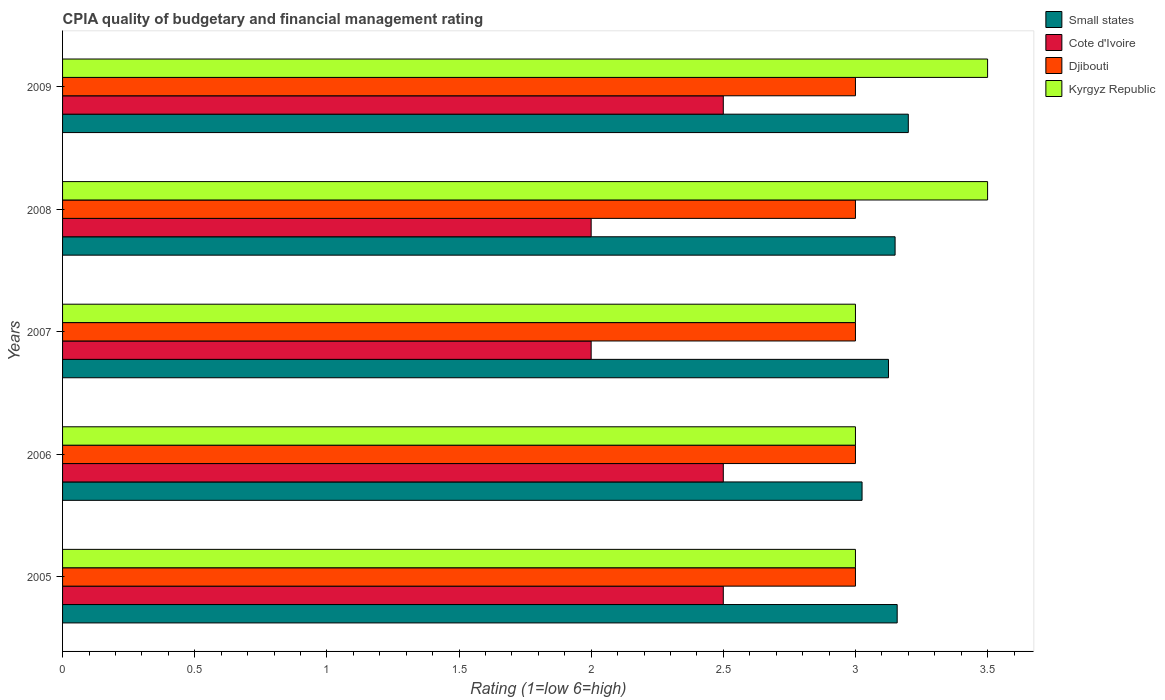How many different coloured bars are there?
Offer a terse response. 4. How many bars are there on the 4th tick from the top?
Provide a succinct answer. 4. What is the CPIA rating in Small states in 2009?
Give a very brief answer. 3.2. Across all years, what is the minimum CPIA rating in Small states?
Give a very brief answer. 3.02. What is the total CPIA rating in Djibouti in the graph?
Your answer should be compact. 15. What is the difference between the CPIA rating in Small states in 2006 and that in 2009?
Your answer should be very brief. -0.18. What is the difference between the CPIA rating in Djibouti in 2006 and the CPIA rating in Small states in 2007?
Your answer should be compact. -0.12. What is the average CPIA rating in Kyrgyz Republic per year?
Provide a succinct answer. 3.2. In how many years, is the CPIA rating in Small states greater than 2.5 ?
Keep it short and to the point. 5. What is the ratio of the CPIA rating in Small states in 2005 to that in 2009?
Ensure brevity in your answer.  0.99. Is the CPIA rating in Kyrgyz Republic in 2005 less than that in 2007?
Offer a very short reply. No. What is the difference between the highest and the second highest CPIA rating in Kyrgyz Republic?
Provide a succinct answer. 0. What is the difference between the highest and the lowest CPIA rating in Small states?
Provide a succinct answer. 0.18. In how many years, is the CPIA rating in Small states greater than the average CPIA rating in Small states taken over all years?
Offer a terse response. 3. Is the sum of the CPIA rating in Djibouti in 2007 and 2009 greater than the maximum CPIA rating in Cote d'Ivoire across all years?
Give a very brief answer. Yes. Is it the case that in every year, the sum of the CPIA rating in Small states and CPIA rating in Kyrgyz Republic is greater than the sum of CPIA rating in Cote d'Ivoire and CPIA rating in Djibouti?
Give a very brief answer. Yes. What does the 4th bar from the top in 2007 represents?
Offer a terse response. Small states. What does the 3rd bar from the bottom in 2005 represents?
Give a very brief answer. Djibouti. Are all the bars in the graph horizontal?
Make the answer very short. Yes. How many years are there in the graph?
Offer a terse response. 5. Does the graph contain any zero values?
Your answer should be very brief. No. Where does the legend appear in the graph?
Provide a short and direct response. Top right. How are the legend labels stacked?
Ensure brevity in your answer.  Vertical. What is the title of the graph?
Give a very brief answer. CPIA quality of budgetary and financial management rating. Does "Montenegro" appear as one of the legend labels in the graph?
Your answer should be compact. No. What is the label or title of the X-axis?
Your answer should be compact. Rating (1=low 6=high). What is the Rating (1=low 6=high) in Small states in 2005?
Provide a short and direct response. 3.16. What is the Rating (1=low 6=high) in Cote d'Ivoire in 2005?
Make the answer very short. 2.5. What is the Rating (1=low 6=high) in Djibouti in 2005?
Keep it short and to the point. 3. What is the Rating (1=low 6=high) of Small states in 2006?
Offer a terse response. 3.02. What is the Rating (1=low 6=high) of Cote d'Ivoire in 2006?
Provide a succinct answer. 2.5. What is the Rating (1=low 6=high) of Kyrgyz Republic in 2006?
Give a very brief answer. 3. What is the Rating (1=low 6=high) of Small states in 2007?
Give a very brief answer. 3.12. What is the Rating (1=low 6=high) in Djibouti in 2007?
Provide a short and direct response. 3. What is the Rating (1=low 6=high) in Small states in 2008?
Offer a terse response. 3.15. What is the Rating (1=low 6=high) of Kyrgyz Republic in 2008?
Ensure brevity in your answer.  3.5. What is the Rating (1=low 6=high) in Cote d'Ivoire in 2009?
Ensure brevity in your answer.  2.5. Across all years, what is the maximum Rating (1=low 6=high) in Cote d'Ivoire?
Keep it short and to the point. 2.5. Across all years, what is the maximum Rating (1=low 6=high) of Kyrgyz Republic?
Offer a terse response. 3.5. Across all years, what is the minimum Rating (1=low 6=high) in Small states?
Keep it short and to the point. 3.02. Across all years, what is the minimum Rating (1=low 6=high) in Cote d'Ivoire?
Your answer should be compact. 2. Across all years, what is the minimum Rating (1=low 6=high) of Djibouti?
Make the answer very short. 3. What is the total Rating (1=low 6=high) of Small states in the graph?
Make the answer very short. 15.66. What is the total Rating (1=low 6=high) of Cote d'Ivoire in the graph?
Ensure brevity in your answer.  11.5. What is the total Rating (1=low 6=high) in Kyrgyz Republic in the graph?
Your response must be concise. 16. What is the difference between the Rating (1=low 6=high) in Small states in 2005 and that in 2006?
Your answer should be very brief. 0.13. What is the difference between the Rating (1=low 6=high) in Cote d'Ivoire in 2005 and that in 2006?
Ensure brevity in your answer.  0. What is the difference between the Rating (1=low 6=high) in Kyrgyz Republic in 2005 and that in 2006?
Your answer should be very brief. 0. What is the difference between the Rating (1=low 6=high) in Small states in 2005 and that in 2007?
Offer a terse response. 0.03. What is the difference between the Rating (1=low 6=high) of Cote d'Ivoire in 2005 and that in 2007?
Your answer should be compact. 0.5. What is the difference between the Rating (1=low 6=high) in Small states in 2005 and that in 2008?
Your answer should be very brief. 0.01. What is the difference between the Rating (1=low 6=high) of Djibouti in 2005 and that in 2008?
Provide a succinct answer. 0. What is the difference between the Rating (1=low 6=high) in Small states in 2005 and that in 2009?
Offer a very short reply. -0.04. What is the difference between the Rating (1=low 6=high) in Cote d'Ivoire in 2005 and that in 2009?
Offer a terse response. 0. What is the difference between the Rating (1=low 6=high) of Djibouti in 2005 and that in 2009?
Your response must be concise. 0. What is the difference between the Rating (1=low 6=high) in Small states in 2006 and that in 2007?
Ensure brevity in your answer.  -0.1. What is the difference between the Rating (1=low 6=high) in Djibouti in 2006 and that in 2007?
Offer a terse response. 0. What is the difference between the Rating (1=low 6=high) in Kyrgyz Republic in 2006 and that in 2007?
Keep it short and to the point. 0. What is the difference between the Rating (1=low 6=high) of Small states in 2006 and that in 2008?
Your answer should be compact. -0.12. What is the difference between the Rating (1=low 6=high) of Djibouti in 2006 and that in 2008?
Your answer should be very brief. 0. What is the difference between the Rating (1=low 6=high) in Small states in 2006 and that in 2009?
Provide a succinct answer. -0.17. What is the difference between the Rating (1=low 6=high) in Cote d'Ivoire in 2006 and that in 2009?
Give a very brief answer. 0. What is the difference between the Rating (1=low 6=high) of Djibouti in 2006 and that in 2009?
Make the answer very short. 0. What is the difference between the Rating (1=low 6=high) in Kyrgyz Republic in 2006 and that in 2009?
Ensure brevity in your answer.  -0.5. What is the difference between the Rating (1=low 6=high) of Small states in 2007 and that in 2008?
Make the answer very short. -0.03. What is the difference between the Rating (1=low 6=high) of Small states in 2007 and that in 2009?
Offer a very short reply. -0.07. What is the difference between the Rating (1=low 6=high) of Kyrgyz Republic in 2007 and that in 2009?
Offer a terse response. -0.5. What is the difference between the Rating (1=low 6=high) in Small states in 2008 and that in 2009?
Your answer should be compact. -0.05. What is the difference between the Rating (1=low 6=high) in Small states in 2005 and the Rating (1=low 6=high) in Cote d'Ivoire in 2006?
Offer a very short reply. 0.66. What is the difference between the Rating (1=low 6=high) of Small states in 2005 and the Rating (1=low 6=high) of Djibouti in 2006?
Offer a terse response. 0.16. What is the difference between the Rating (1=low 6=high) of Small states in 2005 and the Rating (1=low 6=high) of Kyrgyz Republic in 2006?
Ensure brevity in your answer.  0.16. What is the difference between the Rating (1=low 6=high) of Cote d'Ivoire in 2005 and the Rating (1=low 6=high) of Djibouti in 2006?
Keep it short and to the point. -0.5. What is the difference between the Rating (1=low 6=high) in Cote d'Ivoire in 2005 and the Rating (1=low 6=high) in Kyrgyz Republic in 2006?
Provide a short and direct response. -0.5. What is the difference between the Rating (1=low 6=high) in Small states in 2005 and the Rating (1=low 6=high) in Cote d'Ivoire in 2007?
Your response must be concise. 1.16. What is the difference between the Rating (1=low 6=high) of Small states in 2005 and the Rating (1=low 6=high) of Djibouti in 2007?
Ensure brevity in your answer.  0.16. What is the difference between the Rating (1=low 6=high) of Small states in 2005 and the Rating (1=low 6=high) of Kyrgyz Republic in 2007?
Your answer should be very brief. 0.16. What is the difference between the Rating (1=low 6=high) of Small states in 2005 and the Rating (1=low 6=high) of Cote d'Ivoire in 2008?
Your response must be concise. 1.16. What is the difference between the Rating (1=low 6=high) of Small states in 2005 and the Rating (1=low 6=high) of Djibouti in 2008?
Provide a succinct answer. 0.16. What is the difference between the Rating (1=low 6=high) of Small states in 2005 and the Rating (1=low 6=high) of Kyrgyz Republic in 2008?
Give a very brief answer. -0.34. What is the difference between the Rating (1=low 6=high) of Cote d'Ivoire in 2005 and the Rating (1=low 6=high) of Djibouti in 2008?
Your answer should be compact. -0.5. What is the difference between the Rating (1=low 6=high) of Cote d'Ivoire in 2005 and the Rating (1=low 6=high) of Kyrgyz Republic in 2008?
Provide a succinct answer. -1. What is the difference between the Rating (1=low 6=high) of Djibouti in 2005 and the Rating (1=low 6=high) of Kyrgyz Republic in 2008?
Offer a very short reply. -0.5. What is the difference between the Rating (1=low 6=high) of Small states in 2005 and the Rating (1=low 6=high) of Cote d'Ivoire in 2009?
Offer a terse response. 0.66. What is the difference between the Rating (1=low 6=high) in Small states in 2005 and the Rating (1=low 6=high) in Djibouti in 2009?
Provide a short and direct response. 0.16. What is the difference between the Rating (1=low 6=high) in Small states in 2005 and the Rating (1=low 6=high) in Kyrgyz Republic in 2009?
Offer a very short reply. -0.34. What is the difference between the Rating (1=low 6=high) in Cote d'Ivoire in 2005 and the Rating (1=low 6=high) in Kyrgyz Republic in 2009?
Keep it short and to the point. -1. What is the difference between the Rating (1=low 6=high) of Small states in 2006 and the Rating (1=low 6=high) of Djibouti in 2007?
Your answer should be compact. 0.03. What is the difference between the Rating (1=low 6=high) in Small states in 2006 and the Rating (1=low 6=high) in Kyrgyz Republic in 2007?
Your answer should be very brief. 0.03. What is the difference between the Rating (1=low 6=high) in Djibouti in 2006 and the Rating (1=low 6=high) in Kyrgyz Republic in 2007?
Your response must be concise. 0. What is the difference between the Rating (1=low 6=high) in Small states in 2006 and the Rating (1=low 6=high) in Cote d'Ivoire in 2008?
Give a very brief answer. 1.02. What is the difference between the Rating (1=low 6=high) of Small states in 2006 and the Rating (1=low 6=high) of Djibouti in 2008?
Make the answer very short. 0.03. What is the difference between the Rating (1=low 6=high) of Small states in 2006 and the Rating (1=low 6=high) of Kyrgyz Republic in 2008?
Keep it short and to the point. -0.47. What is the difference between the Rating (1=low 6=high) of Cote d'Ivoire in 2006 and the Rating (1=low 6=high) of Djibouti in 2008?
Give a very brief answer. -0.5. What is the difference between the Rating (1=low 6=high) of Cote d'Ivoire in 2006 and the Rating (1=low 6=high) of Kyrgyz Republic in 2008?
Your response must be concise. -1. What is the difference between the Rating (1=low 6=high) in Djibouti in 2006 and the Rating (1=low 6=high) in Kyrgyz Republic in 2008?
Your answer should be very brief. -0.5. What is the difference between the Rating (1=low 6=high) in Small states in 2006 and the Rating (1=low 6=high) in Cote d'Ivoire in 2009?
Ensure brevity in your answer.  0.53. What is the difference between the Rating (1=low 6=high) of Small states in 2006 and the Rating (1=low 6=high) of Djibouti in 2009?
Offer a very short reply. 0.03. What is the difference between the Rating (1=low 6=high) in Small states in 2006 and the Rating (1=low 6=high) in Kyrgyz Republic in 2009?
Ensure brevity in your answer.  -0.47. What is the difference between the Rating (1=low 6=high) of Cote d'Ivoire in 2006 and the Rating (1=low 6=high) of Kyrgyz Republic in 2009?
Offer a terse response. -1. What is the difference between the Rating (1=low 6=high) in Djibouti in 2006 and the Rating (1=low 6=high) in Kyrgyz Republic in 2009?
Your response must be concise. -0.5. What is the difference between the Rating (1=low 6=high) of Small states in 2007 and the Rating (1=low 6=high) of Cote d'Ivoire in 2008?
Make the answer very short. 1.12. What is the difference between the Rating (1=low 6=high) of Small states in 2007 and the Rating (1=low 6=high) of Kyrgyz Republic in 2008?
Your answer should be compact. -0.38. What is the difference between the Rating (1=low 6=high) of Small states in 2007 and the Rating (1=low 6=high) of Kyrgyz Republic in 2009?
Provide a succinct answer. -0.38. What is the difference between the Rating (1=low 6=high) of Djibouti in 2007 and the Rating (1=low 6=high) of Kyrgyz Republic in 2009?
Offer a terse response. -0.5. What is the difference between the Rating (1=low 6=high) in Small states in 2008 and the Rating (1=low 6=high) in Cote d'Ivoire in 2009?
Offer a terse response. 0.65. What is the difference between the Rating (1=low 6=high) in Small states in 2008 and the Rating (1=low 6=high) in Kyrgyz Republic in 2009?
Offer a terse response. -0.35. What is the difference between the Rating (1=low 6=high) in Cote d'Ivoire in 2008 and the Rating (1=low 6=high) in Kyrgyz Republic in 2009?
Provide a short and direct response. -1.5. What is the difference between the Rating (1=low 6=high) of Djibouti in 2008 and the Rating (1=low 6=high) of Kyrgyz Republic in 2009?
Your answer should be compact. -0.5. What is the average Rating (1=low 6=high) in Small states per year?
Your answer should be compact. 3.13. What is the average Rating (1=low 6=high) of Cote d'Ivoire per year?
Keep it short and to the point. 2.3. What is the average Rating (1=low 6=high) in Djibouti per year?
Give a very brief answer. 3. What is the average Rating (1=low 6=high) in Kyrgyz Republic per year?
Your answer should be compact. 3.2. In the year 2005, what is the difference between the Rating (1=low 6=high) of Small states and Rating (1=low 6=high) of Cote d'Ivoire?
Provide a short and direct response. 0.66. In the year 2005, what is the difference between the Rating (1=low 6=high) of Small states and Rating (1=low 6=high) of Djibouti?
Your answer should be very brief. 0.16. In the year 2005, what is the difference between the Rating (1=low 6=high) in Small states and Rating (1=low 6=high) in Kyrgyz Republic?
Your response must be concise. 0.16. In the year 2005, what is the difference between the Rating (1=low 6=high) in Cote d'Ivoire and Rating (1=low 6=high) in Djibouti?
Keep it short and to the point. -0.5. In the year 2005, what is the difference between the Rating (1=low 6=high) in Cote d'Ivoire and Rating (1=low 6=high) in Kyrgyz Republic?
Offer a very short reply. -0.5. In the year 2006, what is the difference between the Rating (1=low 6=high) of Small states and Rating (1=low 6=high) of Cote d'Ivoire?
Provide a short and direct response. 0.53. In the year 2006, what is the difference between the Rating (1=low 6=high) of Small states and Rating (1=low 6=high) of Djibouti?
Make the answer very short. 0.03. In the year 2006, what is the difference between the Rating (1=low 6=high) in Small states and Rating (1=low 6=high) in Kyrgyz Republic?
Your response must be concise. 0.03. In the year 2006, what is the difference between the Rating (1=low 6=high) of Cote d'Ivoire and Rating (1=low 6=high) of Djibouti?
Make the answer very short. -0.5. In the year 2007, what is the difference between the Rating (1=low 6=high) in Small states and Rating (1=low 6=high) in Cote d'Ivoire?
Your answer should be very brief. 1.12. In the year 2007, what is the difference between the Rating (1=low 6=high) in Small states and Rating (1=low 6=high) in Djibouti?
Offer a very short reply. 0.12. In the year 2007, what is the difference between the Rating (1=low 6=high) in Cote d'Ivoire and Rating (1=low 6=high) in Kyrgyz Republic?
Your response must be concise. -1. In the year 2007, what is the difference between the Rating (1=low 6=high) in Djibouti and Rating (1=low 6=high) in Kyrgyz Republic?
Make the answer very short. 0. In the year 2008, what is the difference between the Rating (1=low 6=high) of Small states and Rating (1=low 6=high) of Cote d'Ivoire?
Provide a succinct answer. 1.15. In the year 2008, what is the difference between the Rating (1=low 6=high) in Small states and Rating (1=low 6=high) in Djibouti?
Your response must be concise. 0.15. In the year 2008, what is the difference between the Rating (1=low 6=high) in Small states and Rating (1=low 6=high) in Kyrgyz Republic?
Your answer should be compact. -0.35. In the year 2008, what is the difference between the Rating (1=low 6=high) of Cote d'Ivoire and Rating (1=low 6=high) of Kyrgyz Republic?
Your answer should be very brief. -1.5. In the year 2009, what is the difference between the Rating (1=low 6=high) in Small states and Rating (1=low 6=high) in Djibouti?
Offer a terse response. 0.2. In the year 2009, what is the difference between the Rating (1=low 6=high) of Small states and Rating (1=low 6=high) of Kyrgyz Republic?
Keep it short and to the point. -0.3. In the year 2009, what is the difference between the Rating (1=low 6=high) in Cote d'Ivoire and Rating (1=low 6=high) in Djibouti?
Provide a succinct answer. -0.5. In the year 2009, what is the difference between the Rating (1=low 6=high) in Cote d'Ivoire and Rating (1=low 6=high) in Kyrgyz Republic?
Your response must be concise. -1. What is the ratio of the Rating (1=low 6=high) in Small states in 2005 to that in 2006?
Provide a short and direct response. 1.04. What is the ratio of the Rating (1=low 6=high) of Small states in 2005 to that in 2007?
Offer a very short reply. 1.01. What is the ratio of the Rating (1=low 6=high) of Cote d'Ivoire in 2005 to that in 2007?
Make the answer very short. 1.25. What is the ratio of the Rating (1=low 6=high) in Cote d'Ivoire in 2005 to that in 2008?
Your response must be concise. 1.25. What is the ratio of the Rating (1=low 6=high) of Small states in 2005 to that in 2009?
Provide a short and direct response. 0.99. What is the ratio of the Rating (1=low 6=high) of Cote d'Ivoire in 2005 to that in 2009?
Your answer should be compact. 1. What is the ratio of the Rating (1=low 6=high) in Cote d'Ivoire in 2006 to that in 2007?
Your answer should be compact. 1.25. What is the ratio of the Rating (1=low 6=high) in Djibouti in 2006 to that in 2007?
Provide a short and direct response. 1. What is the ratio of the Rating (1=low 6=high) in Kyrgyz Republic in 2006 to that in 2007?
Make the answer very short. 1. What is the ratio of the Rating (1=low 6=high) of Small states in 2006 to that in 2008?
Make the answer very short. 0.96. What is the ratio of the Rating (1=low 6=high) of Cote d'Ivoire in 2006 to that in 2008?
Make the answer very short. 1.25. What is the ratio of the Rating (1=low 6=high) in Djibouti in 2006 to that in 2008?
Provide a succinct answer. 1. What is the ratio of the Rating (1=low 6=high) in Kyrgyz Republic in 2006 to that in 2008?
Give a very brief answer. 0.86. What is the ratio of the Rating (1=low 6=high) in Small states in 2006 to that in 2009?
Ensure brevity in your answer.  0.95. What is the ratio of the Rating (1=low 6=high) of Kyrgyz Republic in 2006 to that in 2009?
Your response must be concise. 0.86. What is the ratio of the Rating (1=low 6=high) of Djibouti in 2007 to that in 2008?
Offer a terse response. 1. What is the ratio of the Rating (1=low 6=high) in Kyrgyz Republic in 2007 to that in 2008?
Offer a very short reply. 0.86. What is the ratio of the Rating (1=low 6=high) in Small states in 2007 to that in 2009?
Your answer should be compact. 0.98. What is the ratio of the Rating (1=low 6=high) in Djibouti in 2007 to that in 2009?
Provide a short and direct response. 1. What is the ratio of the Rating (1=low 6=high) of Small states in 2008 to that in 2009?
Your answer should be compact. 0.98. What is the ratio of the Rating (1=low 6=high) in Cote d'Ivoire in 2008 to that in 2009?
Provide a succinct answer. 0.8. What is the ratio of the Rating (1=low 6=high) of Kyrgyz Republic in 2008 to that in 2009?
Ensure brevity in your answer.  1. What is the difference between the highest and the second highest Rating (1=low 6=high) in Small states?
Provide a succinct answer. 0.04. What is the difference between the highest and the second highest Rating (1=low 6=high) of Cote d'Ivoire?
Your answer should be very brief. 0. What is the difference between the highest and the second highest Rating (1=low 6=high) in Djibouti?
Provide a succinct answer. 0. What is the difference between the highest and the lowest Rating (1=low 6=high) of Small states?
Offer a very short reply. 0.17. What is the difference between the highest and the lowest Rating (1=low 6=high) of Cote d'Ivoire?
Offer a terse response. 0.5. 